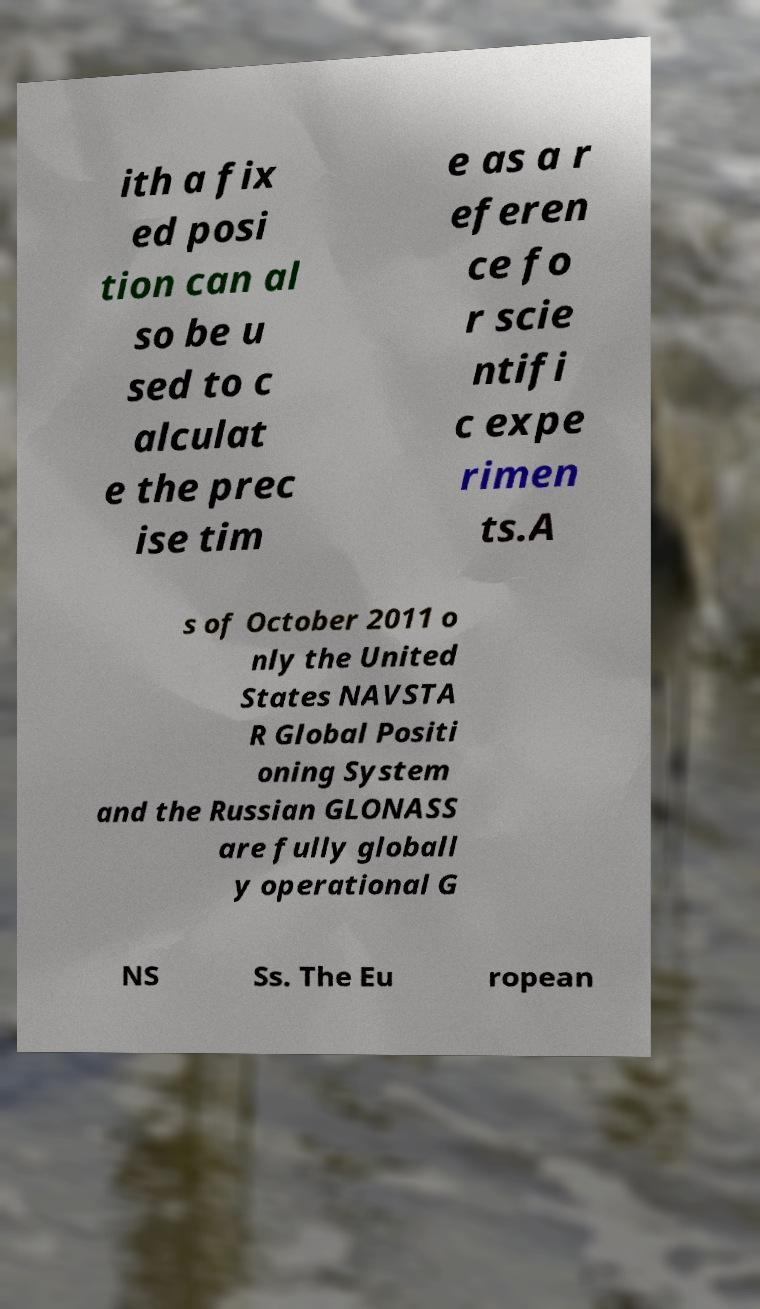Can you accurately transcribe the text from the provided image for me? ith a fix ed posi tion can al so be u sed to c alculat e the prec ise tim e as a r eferen ce fo r scie ntifi c expe rimen ts.A s of October 2011 o nly the United States NAVSTA R Global Positi oning System and the Russian GLONASS are fully globall y operational G NS Ss. The Eu ropean 